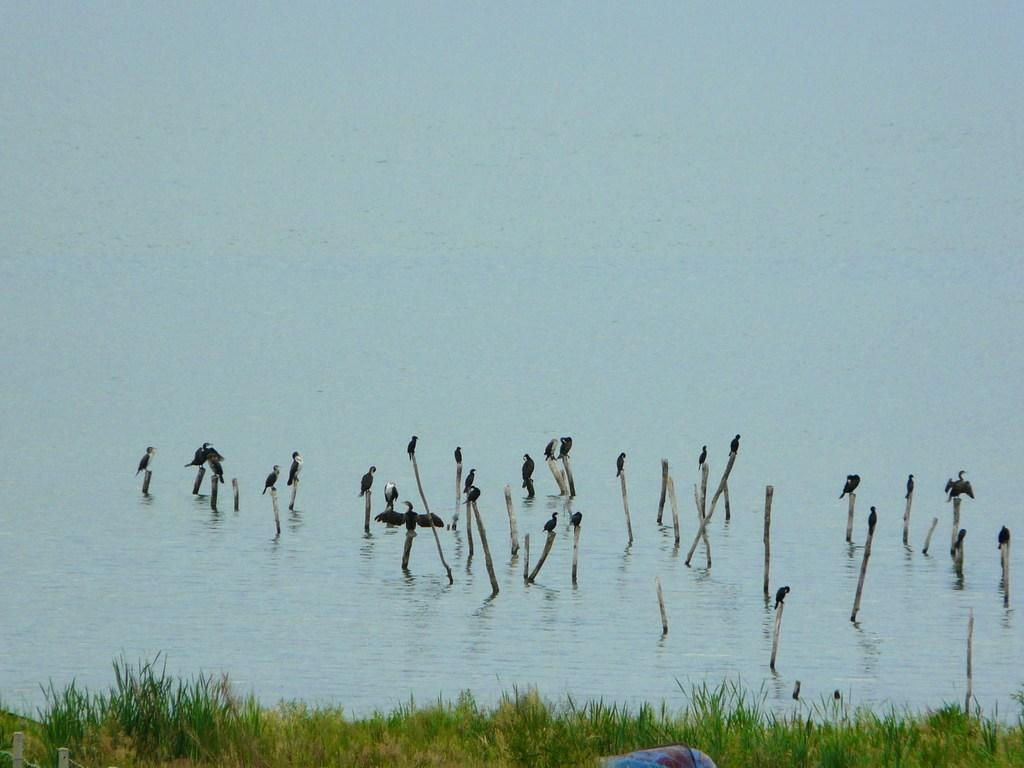What is the main subject of the image? The main subject of the image is many birds. What are the birds standing on? The birds are standing on sticks. Where are the sticks located? The sticks are in the river. What type of landscape is visible in the image? There is a grassland in front of the river. How many knees can be seen in the image? There are no knees visible in the image, as it features birds standing on sticks in a river. What type of dust is present in the image? There is no dust present in the image; it features birds standing on sticks in a river. 